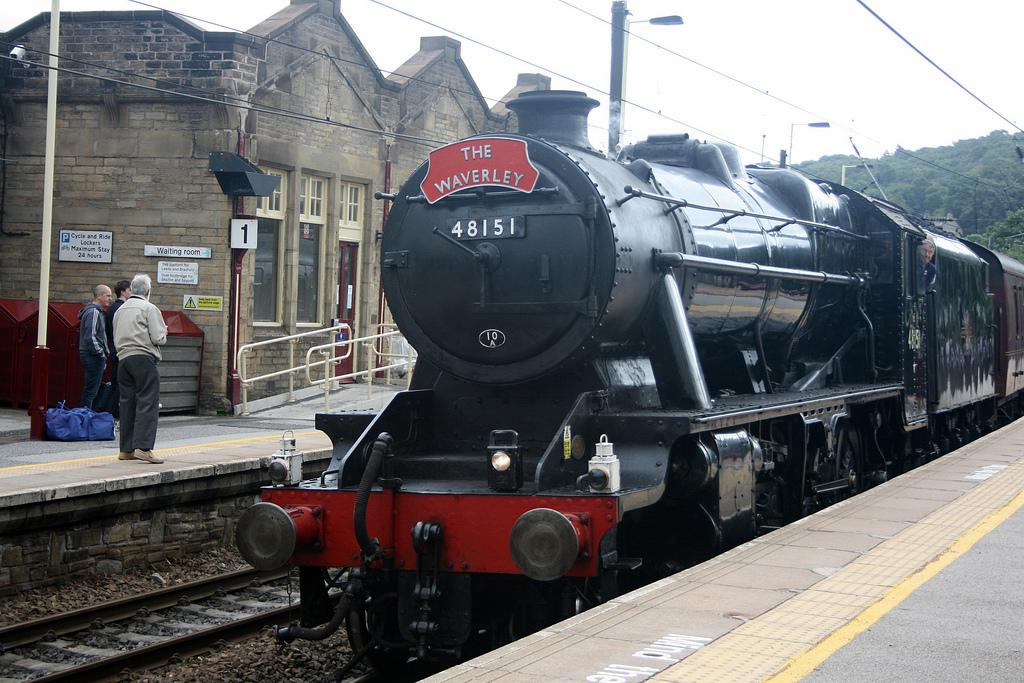Question: what are the hills in the background covered with?
Choices:
A. Trees.
B. Grass.
C. Flowers.
D. Rocks.
Answer with the letter. Answer: A Question: where are the yellow painted lines?
Choices:
A. In the middle of the street.
B. On the sign.
C. On the platform.
D. On the building.
Answer with the letter. Answer: C Question: who is by the blue bag?
Choices:
A. A bald man.
B. A dog.
C. A woman.
D. The police.
Answer with the letter. Answer: A Question: how old are the men?
Choices:
A. 32.
B. Elderly.
C. Middle aged.
D. Young.
Answer with the letter. Answer: B Question: where are the men?
Choices:
A. On the truck.
B. In the house.
C. In the restroom.
D. On a train platform.
Answer with the letter. Answer: D Question: why are they there?
Choices:
A. To eat.
B. To watch television.
C. To wait for the train.
D. To play basketball.
Answer with the letter. Answer: C Question: what is the air temperature?
Choices:
A. Warm.
B. Hot.
C. Cool.
D. Chilly.
Answer with the letter. Answer: D Question: why are the buildings dingy?
Choices:
A. Run down.
B. Old.
C. From all the crack heads.
D. From the train smoke.
Answer with the letter. Answer: D Question: what is on the side of the building?
Choices:
A. A row of windows.
B. A billboard.
C. A fire escape.
D. Several signs.
Answer with the letter. Answer: D Question: where do the handrails lead?
Choices:
A. Into the subway station.
B. To the upstairs bedroom.
C. To the building.
D. Across the bridge.
Answer with the letter. Answer: C Question: what waits at a railroad station?
Choices:
A. A steam engine.
B. A passenger train.
C. People.
D. Cars.
Answer with the letter. Answer: A Question: what color is the train?
Choices:
A. Gray.
B. White and pink.
C. Red.
D. Black and red.
Answer with the letter. Answer: D Question: how many train tracks are there?
Choices:
A. Four.
B. Nine.
C. Twelve.
D. Two.
Answer with the letter. Answer: D Question: what is painted on the platform?
Choices:
A. A mural.
B. A yellow line.
C. A warning.
D. An arrow.
Answer with the letter. Answer: B Question: where are three men standing?
Choices:
A. On the street.
B. On the sidewalk.
C. On the road.
D. On the platform.
Answer with the letter. Answer: D Question: what are the buildings made of?
Choices:
A. Concrete.
B. Stone.
C. Steel.
D. Cement.
Answer with the letter. Answer: B Question: where are the group of people standing?
Choices:
A. On a sidewalk.
B. On a street.
C. On a train platform near a station.
D. On a road.
Answer with the letter. Answer: C Question: what does the man on the left have?
Choices:
A. A large blue duffle bag.
B. Car keys.
C. Suitcase.
D. Luggage.
Answer with the letter. Answer: A Question: what is white?
Choices:
A. Snow.
B. A pole.
C. A cat.
D. A house.
Answer with the letter. Answer: B Question: what can be seen rising above the train in the background?
Choices:
A. A group of skyscrapers.
B. A mountain range.
C. Green hills.
D. A large statue.
Answer with the letter. Answer: C 